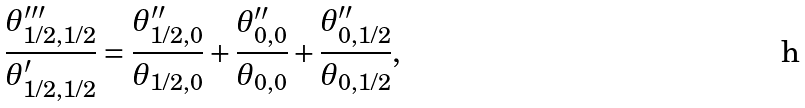<formula> <loc_0><loc_0><loc_500><loc_500>\frac { \theta _ { 1 / 2 , 1 / 2 } ^ { \prime \prime \prime } } { \theta _ { 1 / 2 , 1 / 2 } ^ { \prime } } = \frac { \theta _ { 1 / 2 , 0 } ^ { \prime \prime } } { \theta _ { 1 / 2 , 0 } } + \frac { \theta _ { 0 , 0 } ^ { \prime \prime } } { \theta _ { 0 , 0 } } + \frac { \theta _ { 0 , 1 / 2 } ^ { \prime \prime } } { \theta _ { 0 , 1 / 2 } } ,</formula> 